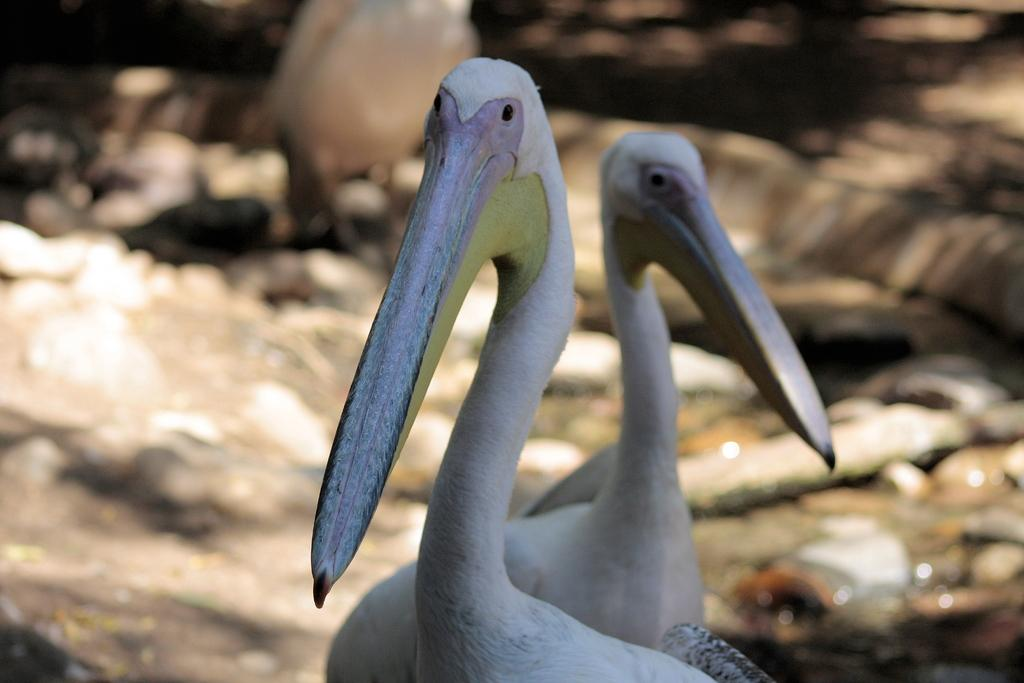What type of animals can be seen in the image? There are two water birds in the image. What is a distinctive feature of these birds? The birds have long beaks. What can be found at the bottom of the image? There are stones at the bottom of the image. What is the primary element visible in the image? There is water visible in the image. What type of fuel is being used by the visitor in the image? There is no visitor present in the image, and therefore no fuel usage can be observed. What type of place is depicted in the image? The image does not depict a specific place; it simply shows two water birds in their natural environment. 